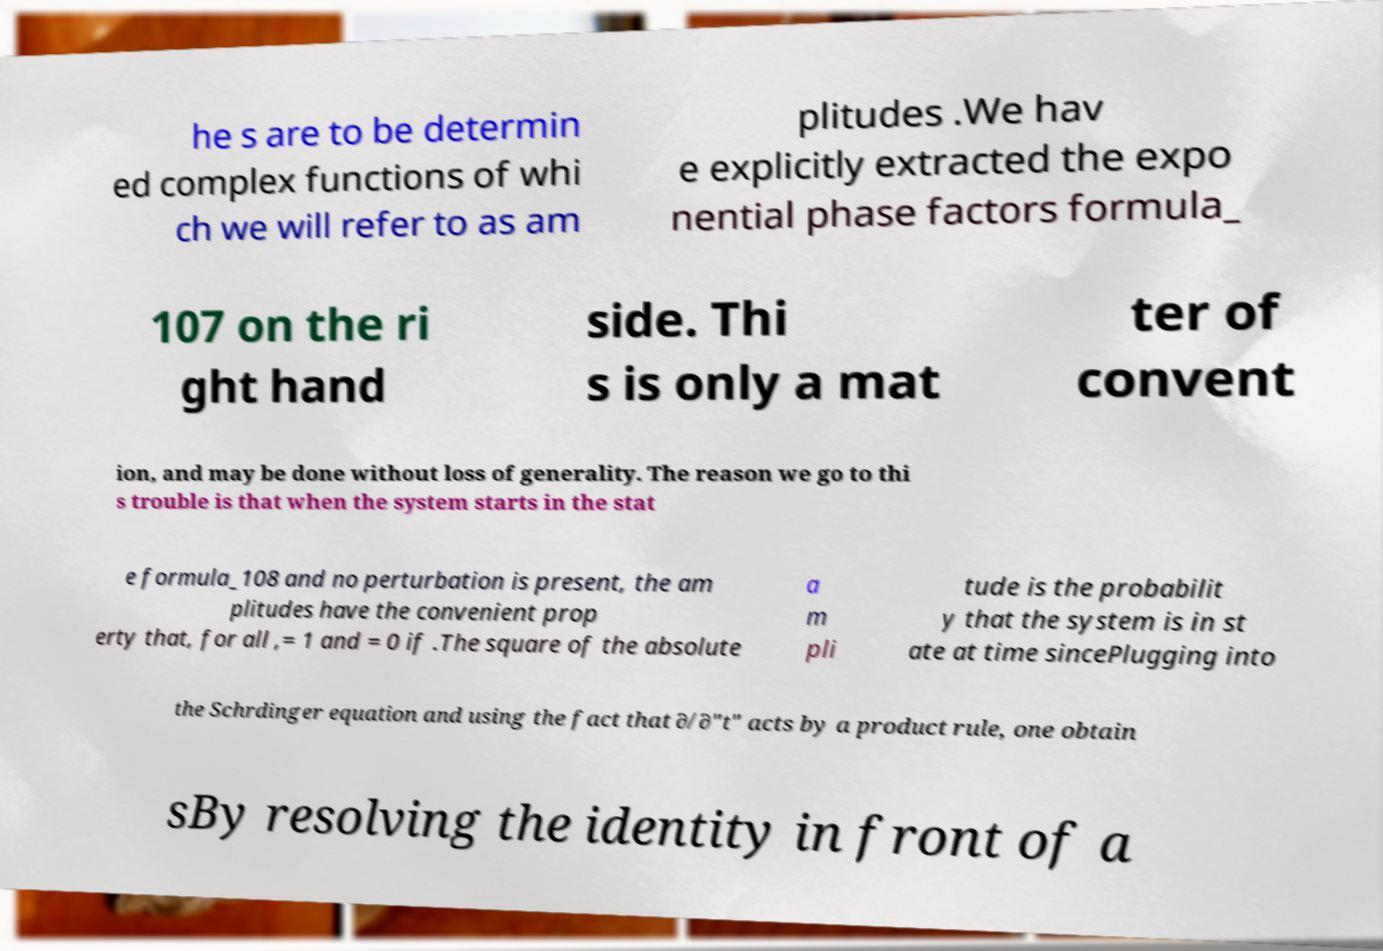What messages or text are displayed in this image? I need them in a readable, typed format. he s are to be determin ed complex functions of whi ch we will refer to as am plitudes .We hav e explicitly extracted the expo nential phase factors formula_ 107 on the ri ght hand side. Thi s is only a mat ter of convent ion, and may be done without loss of generality. The reason we go to thi s trouble is that when the system starts in the stat e formula_108 and no perturbation is present, the am plitudes have the convenient prop erty that, for all ,= 1 and = 0 if .The square of the absolute a m pli tude is the probabilit y that the system is in st ate at time sincePlugging into the Schrdinger equation and using the fact that ∂/∂"t" acts by a product rule, one obtain sBy resolving the identity in front of a 